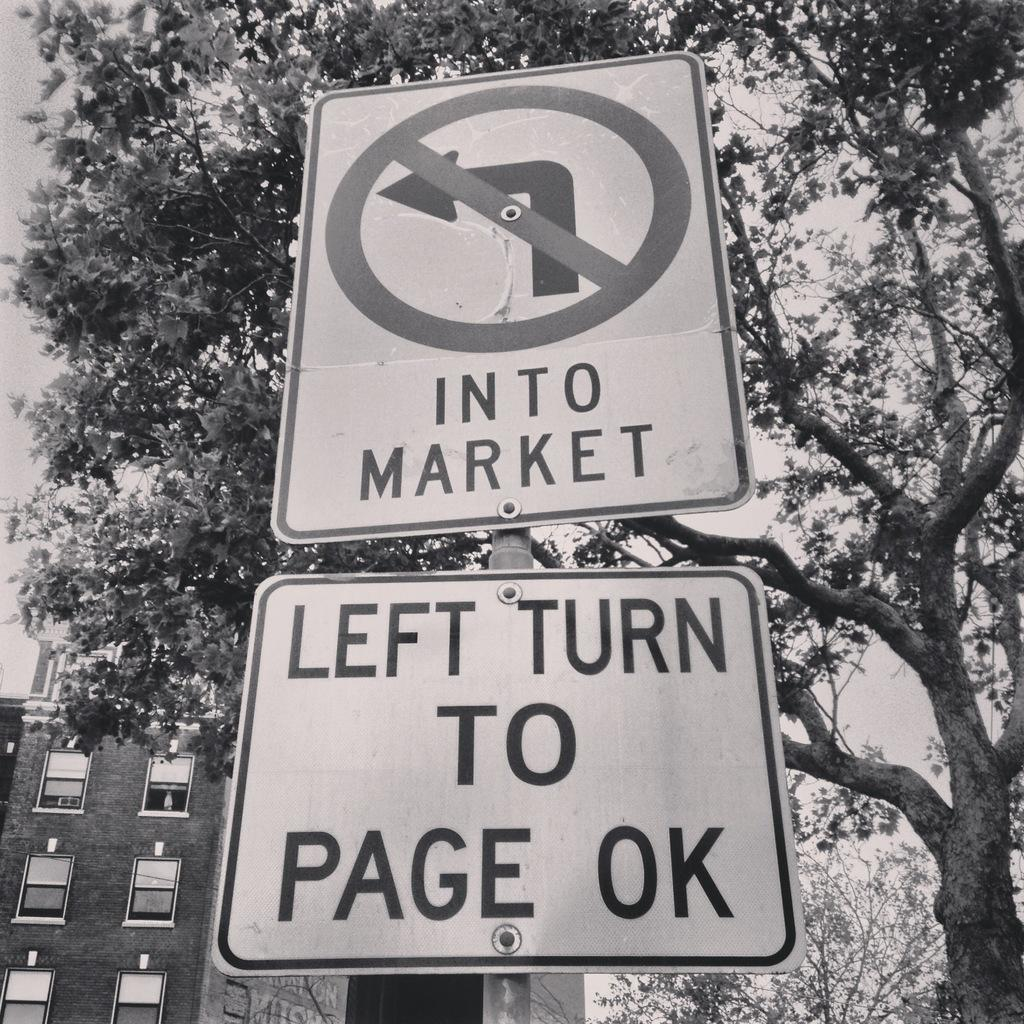What can be seen on the pole in the image? There are two signs on a pole in the image. What type of vegetation is on the right side of the image? There are trees on the right side of the image. What structure is located on the left side of the image? There is a building on the left side of the image. What is visible in the background of the image? The sky is visible in the background of the image. What arithmetic problem is being taught on the signs in the image? There is no arithmetic problem being taught on the signs in the image; they are simply signs on a pole. What type of beam is supporting the building on the left side of the image? There is no beam visible in the image; it only shows a building on the left side. 